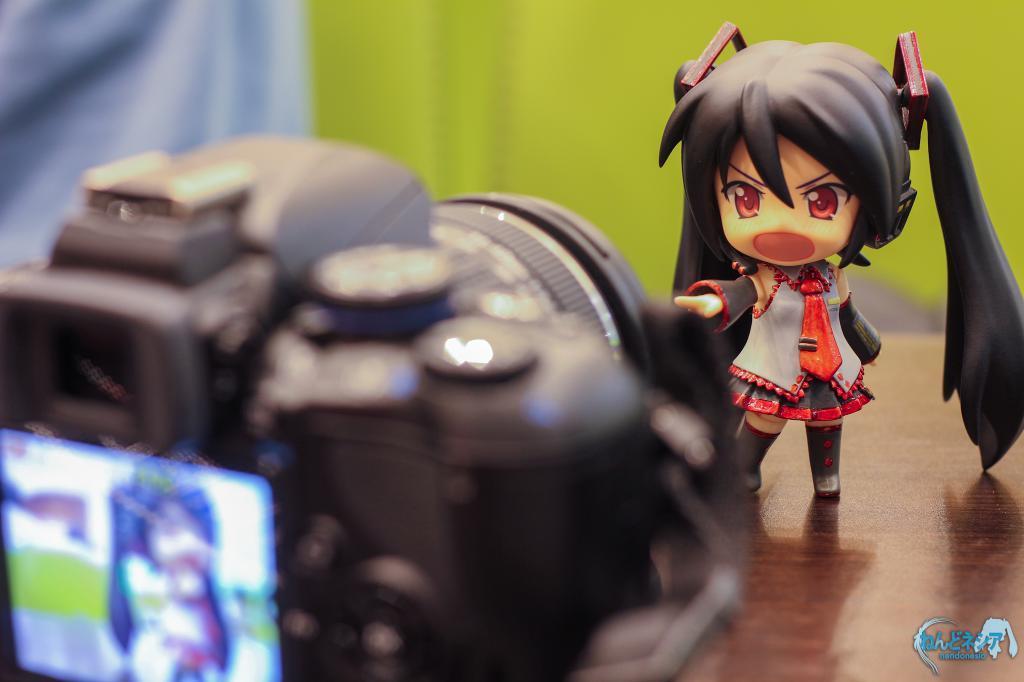In one or two sentences, can you explain what this image depicts? In this image I can see a camera which is black in color on the brown colored surface and on the surface I can see a girl toy who is wearing white, black and red colored dress. In the background I can see the green and blue colored surface. 